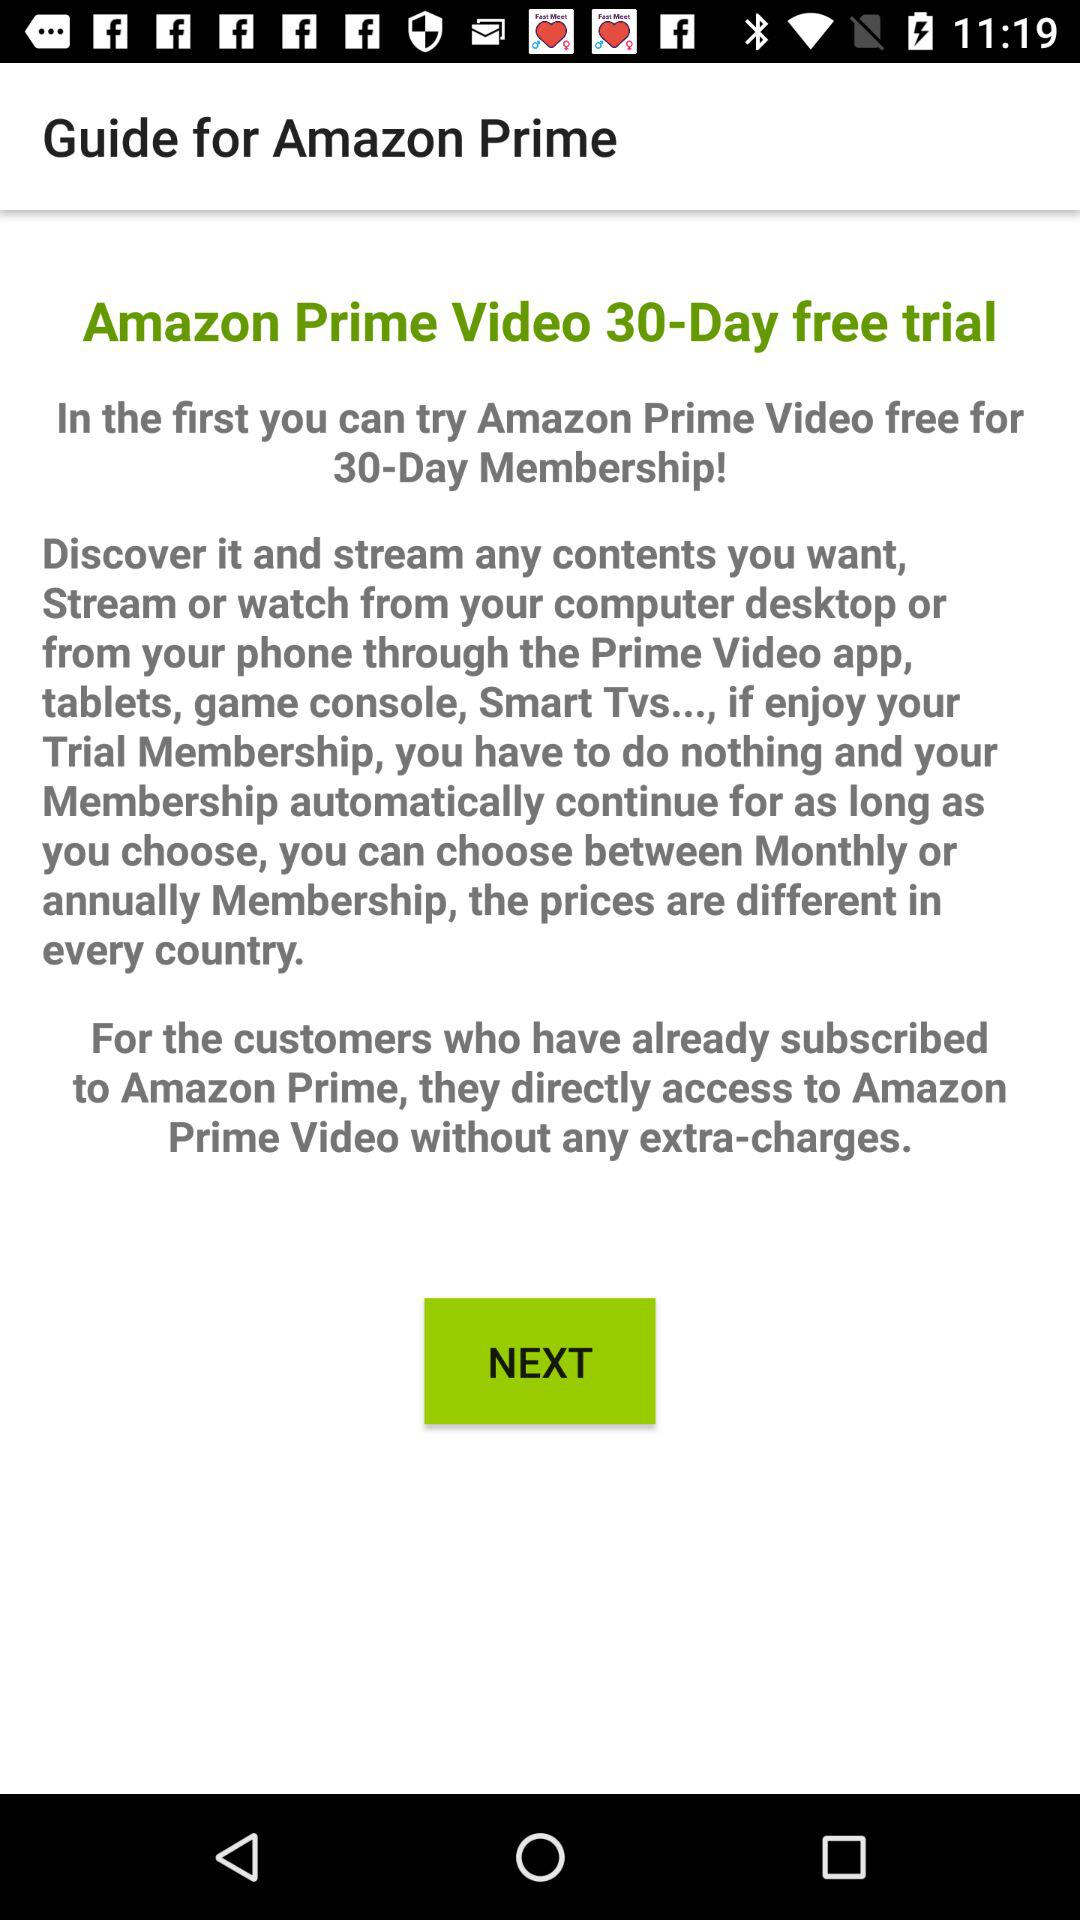What is the email address to sign up for the free trial?
When the provided information is insufficient, respond with <no answer>. <no answer> 